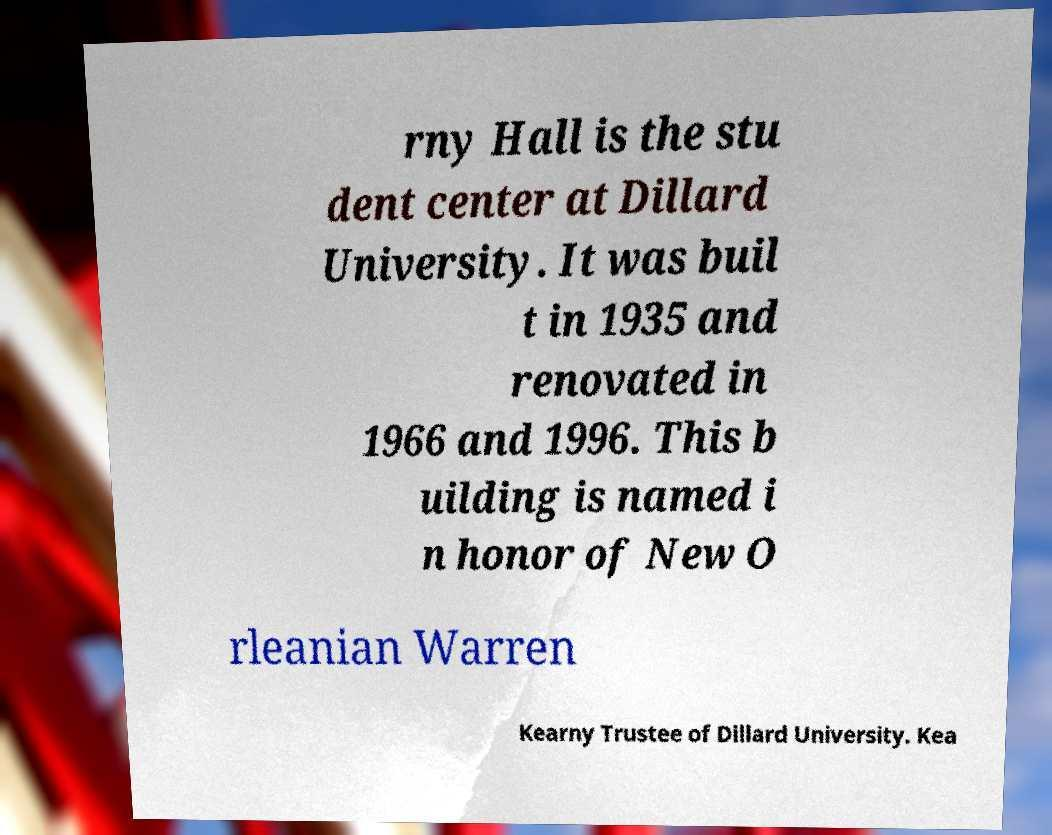I need the written content from this picture converted into text. Can you do that? rny Hall is the stu dent center at Dillard University. It was buil t in 1935 and renovated in 1966 and 1996. This b uilding is named i n honor of New O rleanian Warren Kearny Trustee of Dillard University. Kea 